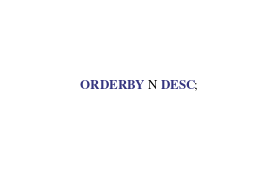<code> <loc_0><loc_0><loc_500><loc_500><_SQL_>ORDER BY N DESC;


</code> 